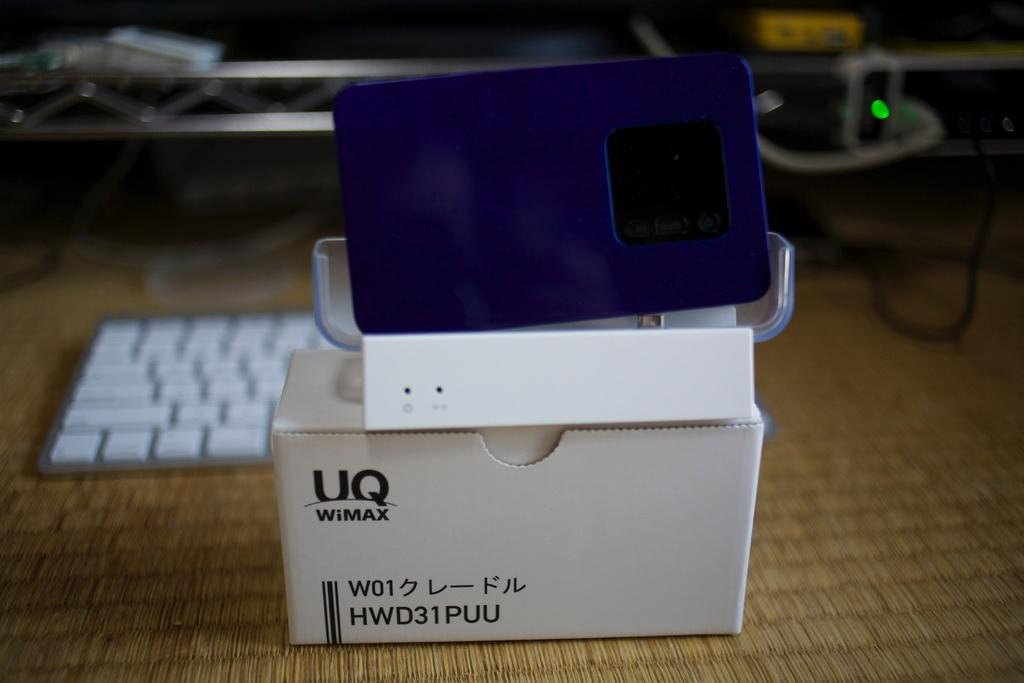Provide a one-sentence caption for the provided image. a white box with a device from UQ WiMAX. 